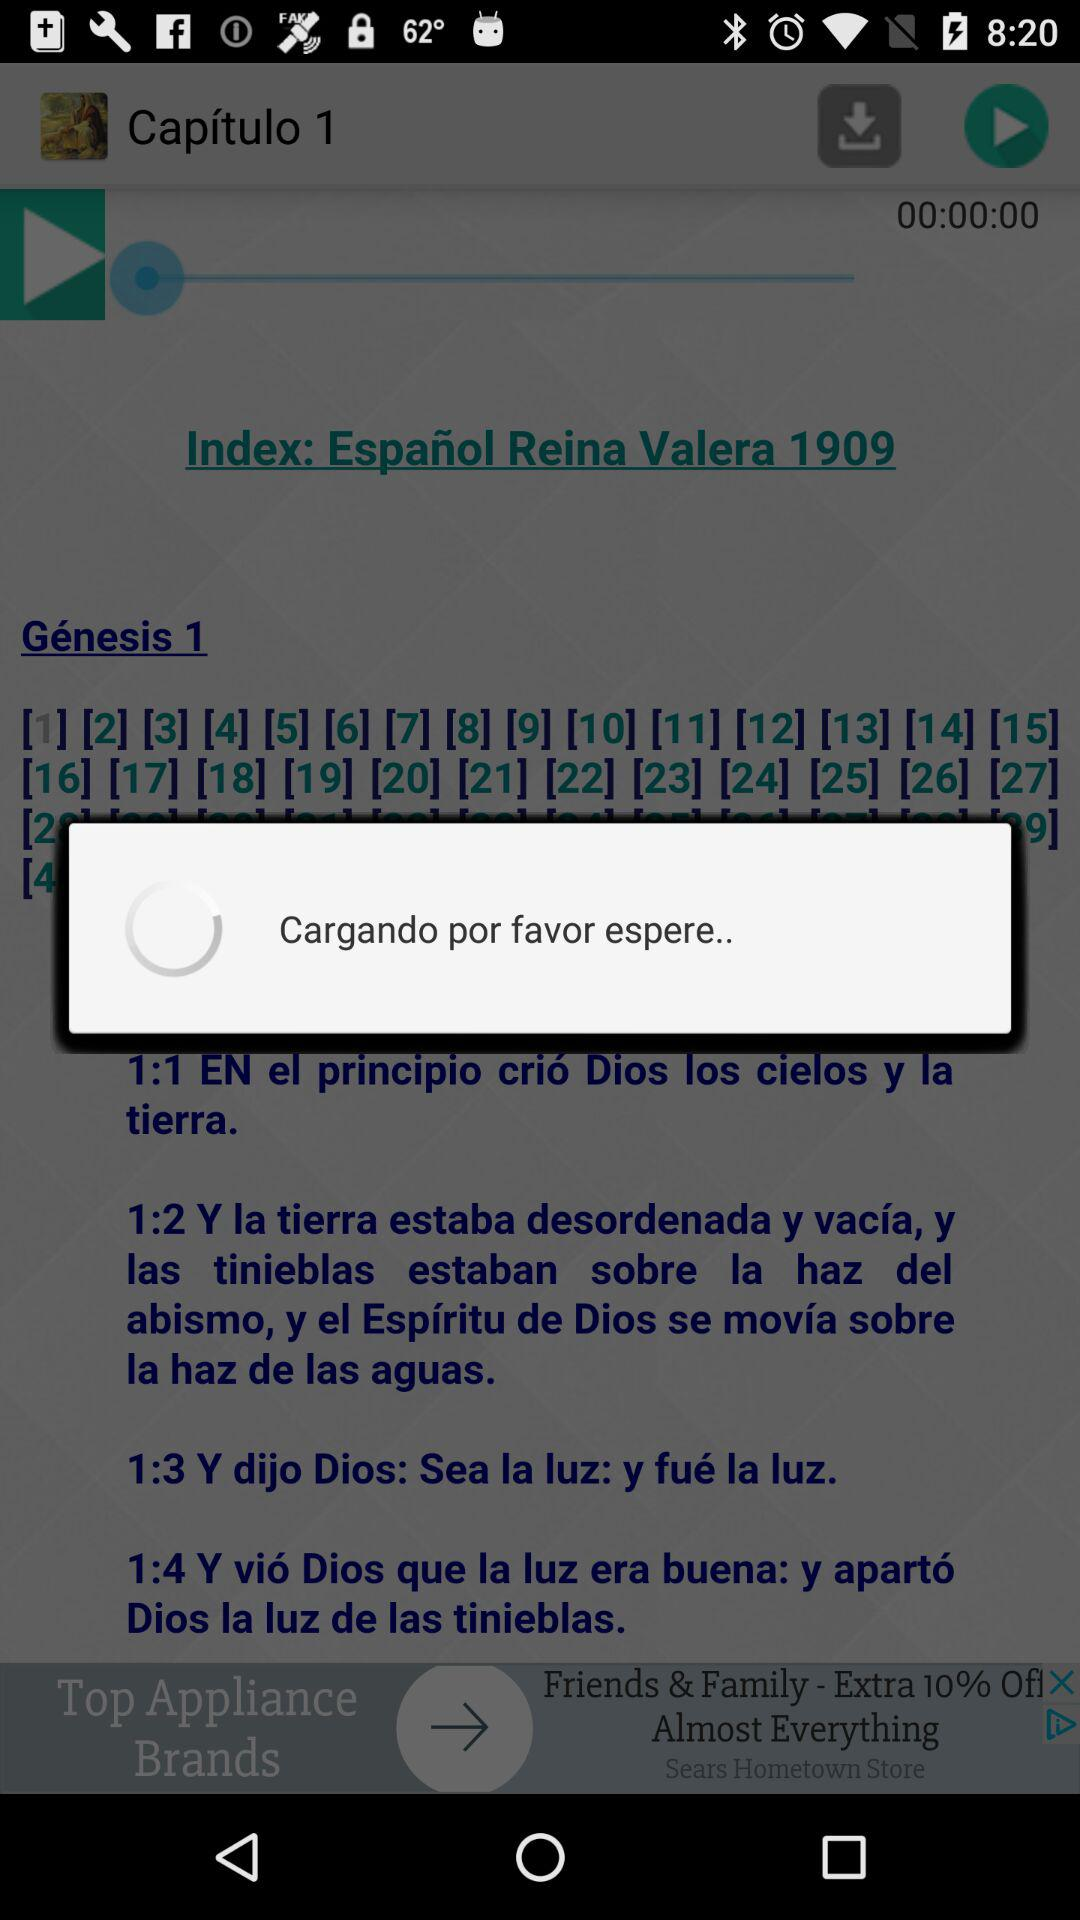What is the name of the application? The application name is "TRUSTED". 